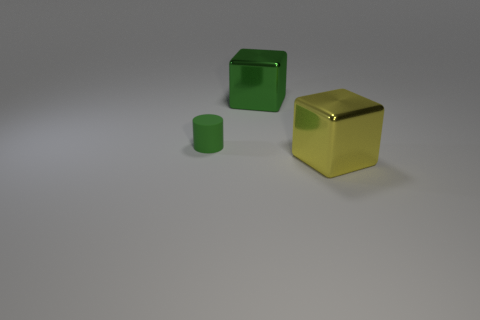Is there any other thing that is the same size as the matte thing?
Your response must be concise. No. There is a shiny thing that is the same size as the green cube; what color is it?
Provide a short and direct response. Yellow. What number of big objects are either rubber things or green rubber blocks?
Provide a short and direct response. 0. Are there an equal number of rubber objects that are behind the tiny green cylinder and large yellow metallic blocks left of the big yellow shiny block?
Offer a very short reply. Yes. What number of yellow metal blocks have the same size as the cylinder?
Make the answer very short. 0. What number of green objects are either small shiny cylinders or small cylinders?
Give a very brief answer. 1. Is the number of large metallic cubes on the right side of the yellow metal cube the same as the number of things?
Provide a succinct answer. No. How big is the thing that is in front of the tiny matte object?
Your answer should be compact. Large. What number of other yellow objects are the same shape as the yellow shiny object?
Your response must be concise. 0. What is the object that is in front of the large green thing and to the right of the small rubber object made of?
Give a very brief answer. Metal. 